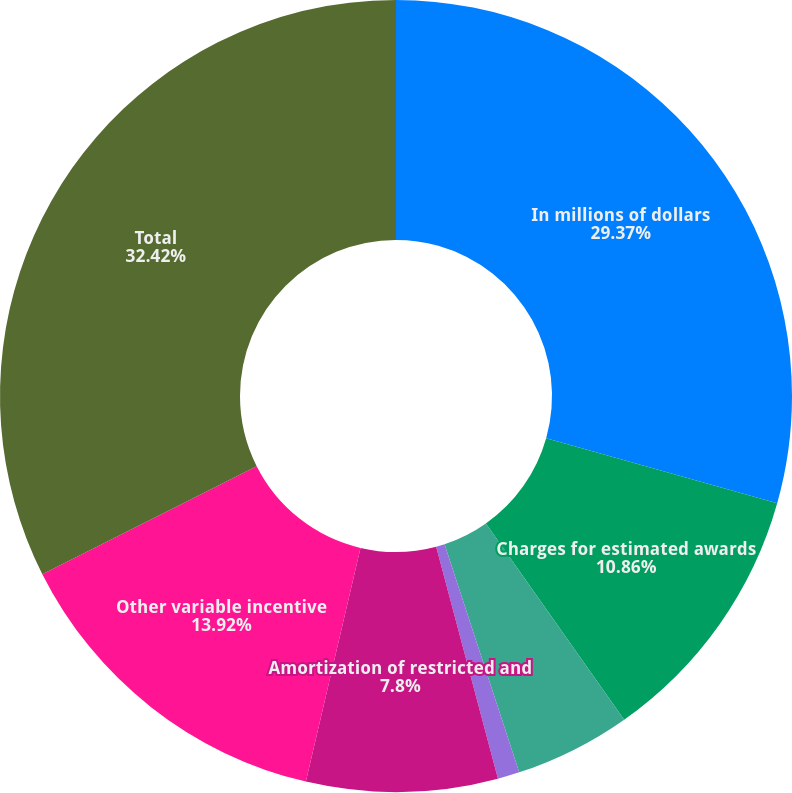<chart> <loc_0><loc_0><loc_500><loc_500><pie_chart><fcel>In millions of dollars<fcel>Charges for estimated awards<fcel>Amortization of deferred cash<fcel>Immediately vested stock award<fcel>Amortization of restricted and<fcel>Other variable incentive<fcel>Total<nl><fcel>29.37%<fcel>10.86%<fcel>4.74%<fcel>0.89%<fcel>7.8%<fcel>13.92%<fcel>32.43%<nl></chart> 